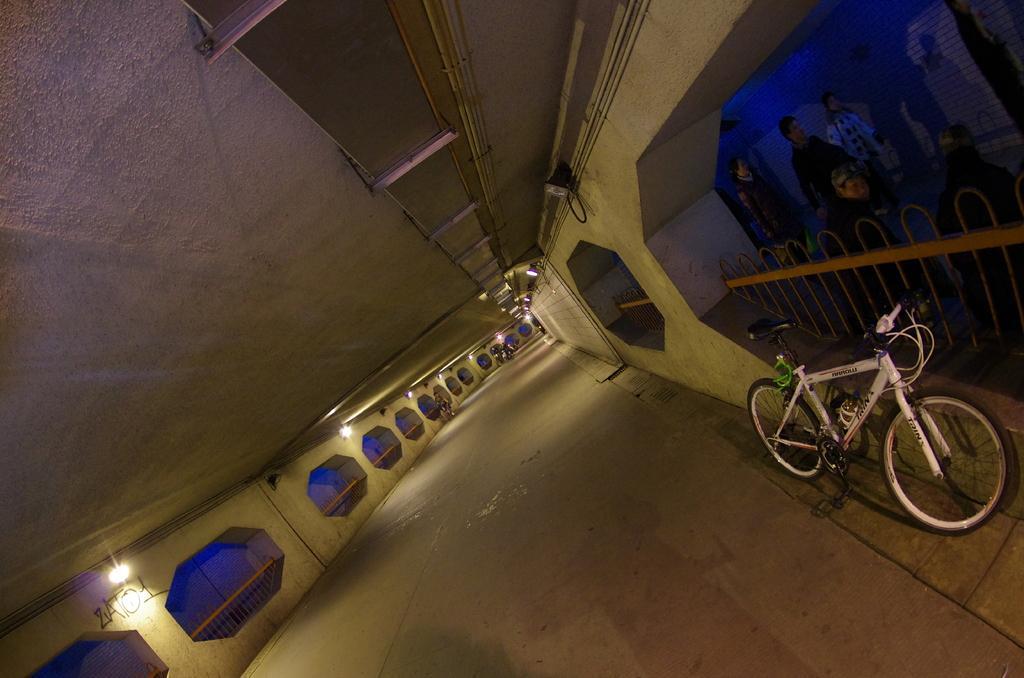In one or two sentences, can you explain what this image depicts? In this picture we can see a bicycle and a few people. We can see some fencing on both sides of the image. There are a few lights and other objects are visible on top. 